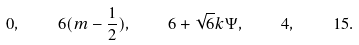Convert formula to latex. <formula><loc_0><loc_0><loc_500><loc_500>0 , \quad 6 ( m - \frac { 1 } { 2 } ) , \quad 6 + \sqrt { 6 } k \Psi , \quad 4 , \quad 1 5 .</formula> 